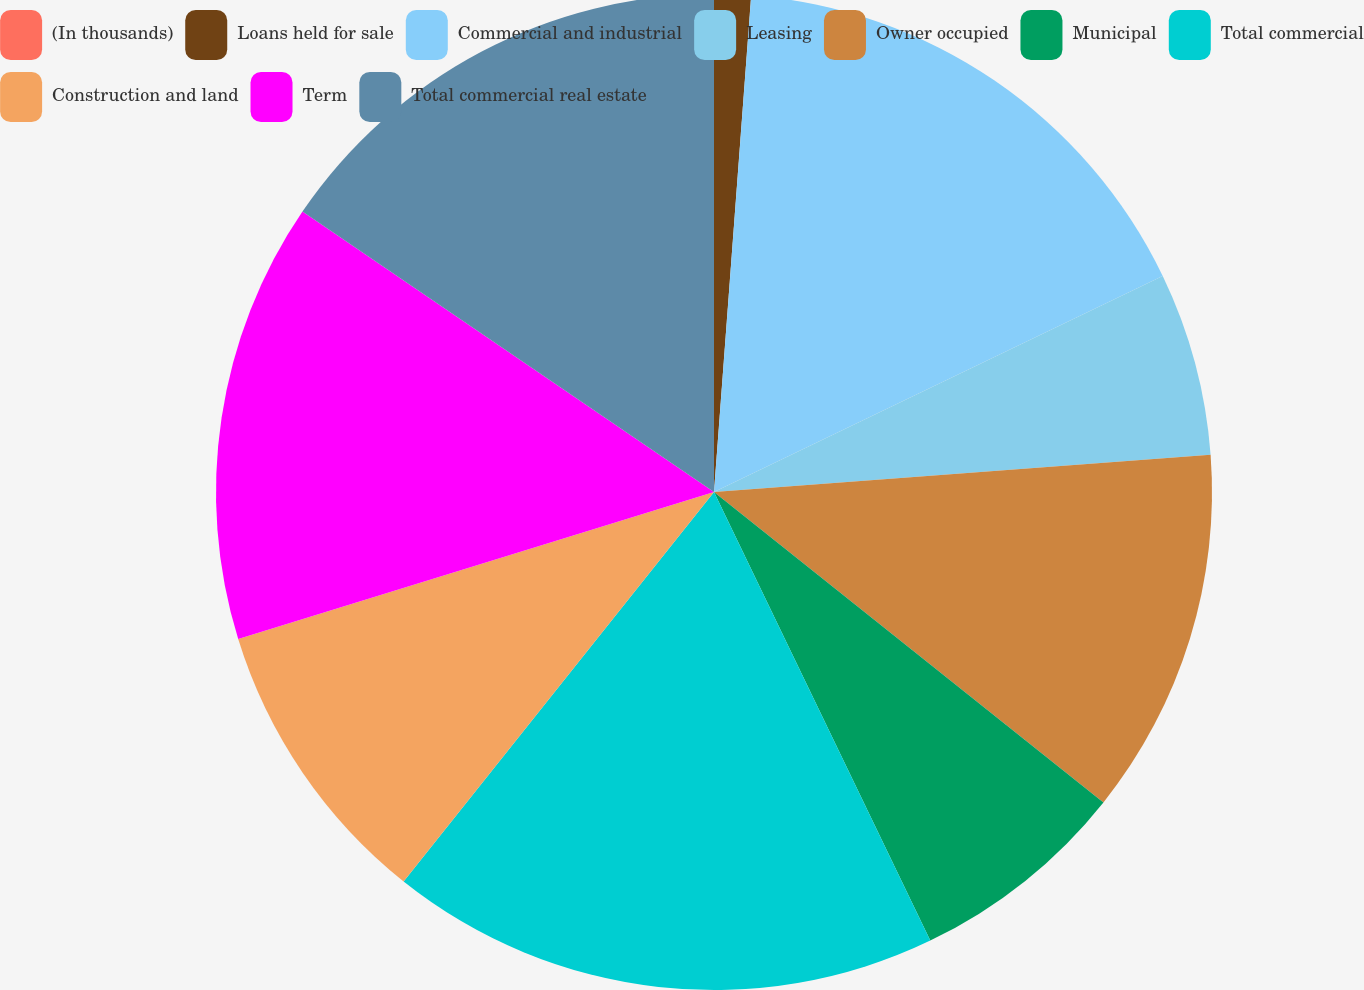<chart> <loc_0><loc_0><loc_500><loc_500><pie_chart><fcel>(In thousands)<fcel>Loans held for sale<fcel>Commercial and industrial<fcel>Leasing<fcel>Owner occupied<fcel>Municipal<fcel>Total commercial<fcel>Construction and land<fcel>Term<fcel>Total commercial real estate<nl><fcel>0.0%<fcel>1.19%<fcel>16.67%<fcel>5.95%<fcel>11.9%<fcel>7.14%<fcel>17.86%<fcel>9.52%<fcel>14.29%<fcel>15.48%<nl></chart> 